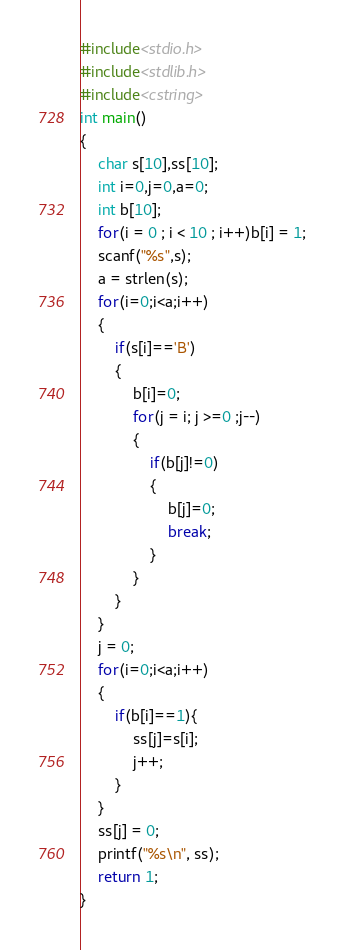Convert code to text. <code><loc_0><loc_0><loc_500><loc_500><_C++_>#include<stdio.h>
#include<stdlib.h>
#include<cstring>
int main()
{
	char s[10],ss[10];
	int i=0,j=0,a=0;
	int b[10];
	for(i = 0 ; i < 10 ; i++)b[i] = 1;
	scanf("%s",s);
	a = strlen(s);
	for(i=0;i<a;i++)
	{
		if(s[i]=='B')
		{
			b[i]=0;
			for(j = i; j >=0 ;j--)
			{
				if(b[j]!=0)
				{
					b[j]=0;
					break;
				}
			}
		}
	}
	j = 0;
	for(i=0;i<a;i++)
	{
		if(b[i]==1){
			ss[j]=s[i];
			j++;
		}
	}
	ss[j] = 0;
	printf("%s\n", ss);
	return 1;
}</code> 